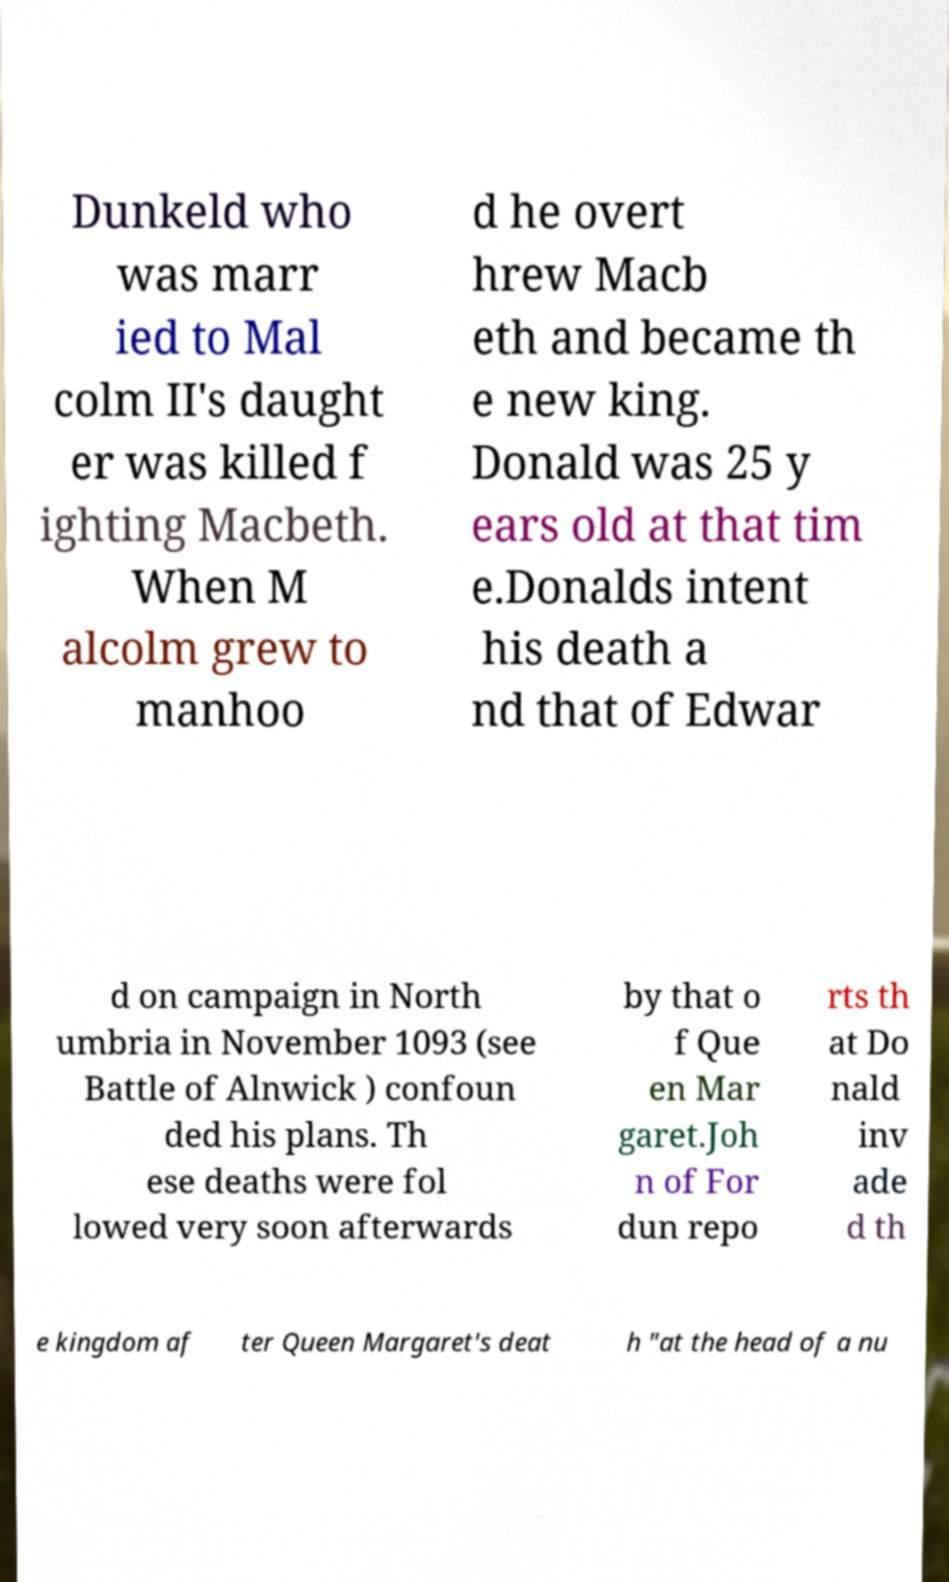For documentation purposes, I need the text within this image transcribed. Could you provide that? Dunkeld who was marr ied to Mal colm II's daught er was killed f ighting Macbeth. When M alcolm grew to manhoo d he overt hrew Macb eth and became th e new king. Donald was 25 y ears old at that tim e.Donalds intent his death a nd that of Edwar d on campaign in North umbria in November 1093 (see Battle of Alnwick ) confoun ded his plans. Th ese deaths were fol lowed very soon afterwards by that o f Que en Mar garet.Joh n of For dun repo rts th at Do nald inv ade d th e kingdom af ter Queen Margaret's deat h "at the head of a nu 